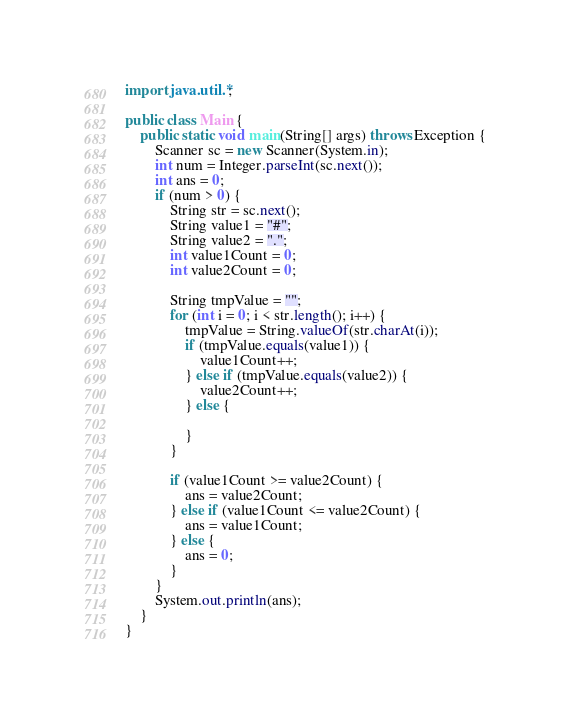<code> <loc_0><loc_0><loc_500><loc_500><_Java_>import java.util.*;

public class Main {
    public static void main(String[] args) throws Exception {
        Scanner sc = new Scanner(System.in);
        int num = Integer.parseInt(sc.next());
        int ans = 0;
        if (num > 0) {
            String str = sc.next();
            String value1 = "#";
            String value2 = ".";
            int value1Count = 0;
            int value2Count = 0;
            
            String tmpValue = "";
            for (int i = 0; i < str.length(); i++) {
                tmpValue = String.valueOf(str.charAt(i));
                if (tmpValue.equals(value1)) {
                    value1Count++;
                } else if (tmpValue.equals(value2)) {
                    value2Count++;
                } else {
                    
                }
            }
            
            if (value1Count >= value2Count) {
                ans = value2Count;
            } else if (value1Count <= value2Count) {
                ans = value1Count;
            } else {
                ans = 0;
            }
        }
        System.out.println(ans);
    }
}
</code> 